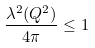Convert formula to latex. <formula><loc_0><loc_0><loc_500><loc_500>\frac { \lambda ^ { 2 } ( Q ^ { 2 } ) } { 4 \pi } \leq 1</formula> 